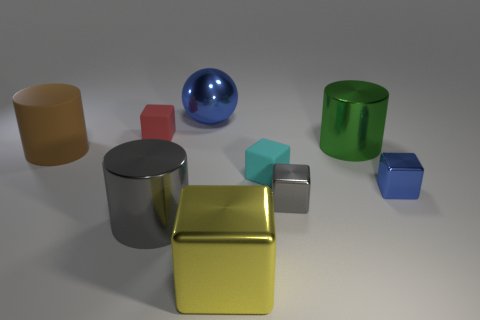Does the gray cylinder have the same size as the gray thing on the right side of the big ball? no 